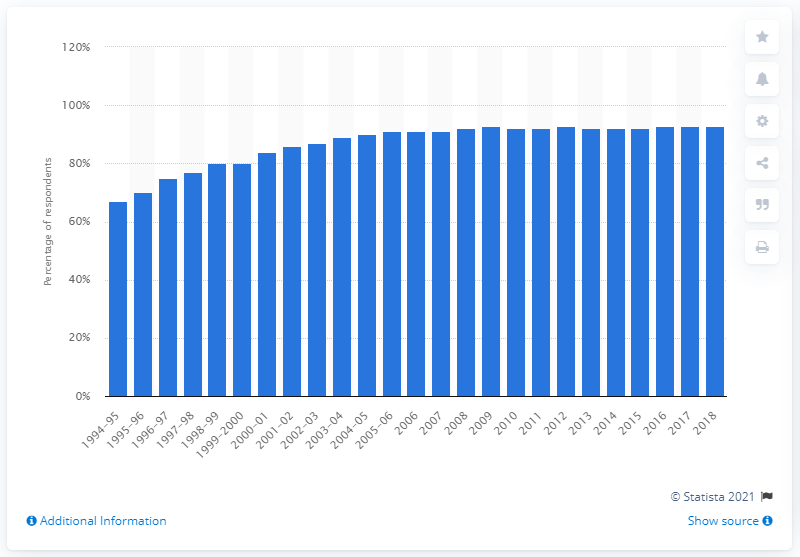Identify some key points in this picture. In 2018, it was estimated that 93% of households in the United States owned a microwave oven. 